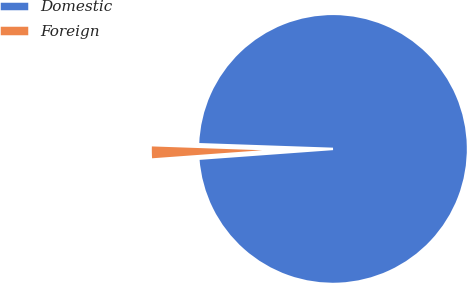Convert chart to OTSL. <chart><loc_0><loc_0><loc_500><loc_500><pie_chart><fcel>Domestic<fcel>Foreign<nl><fcel>98.29%<fcel>1.71%<nl></chart> 